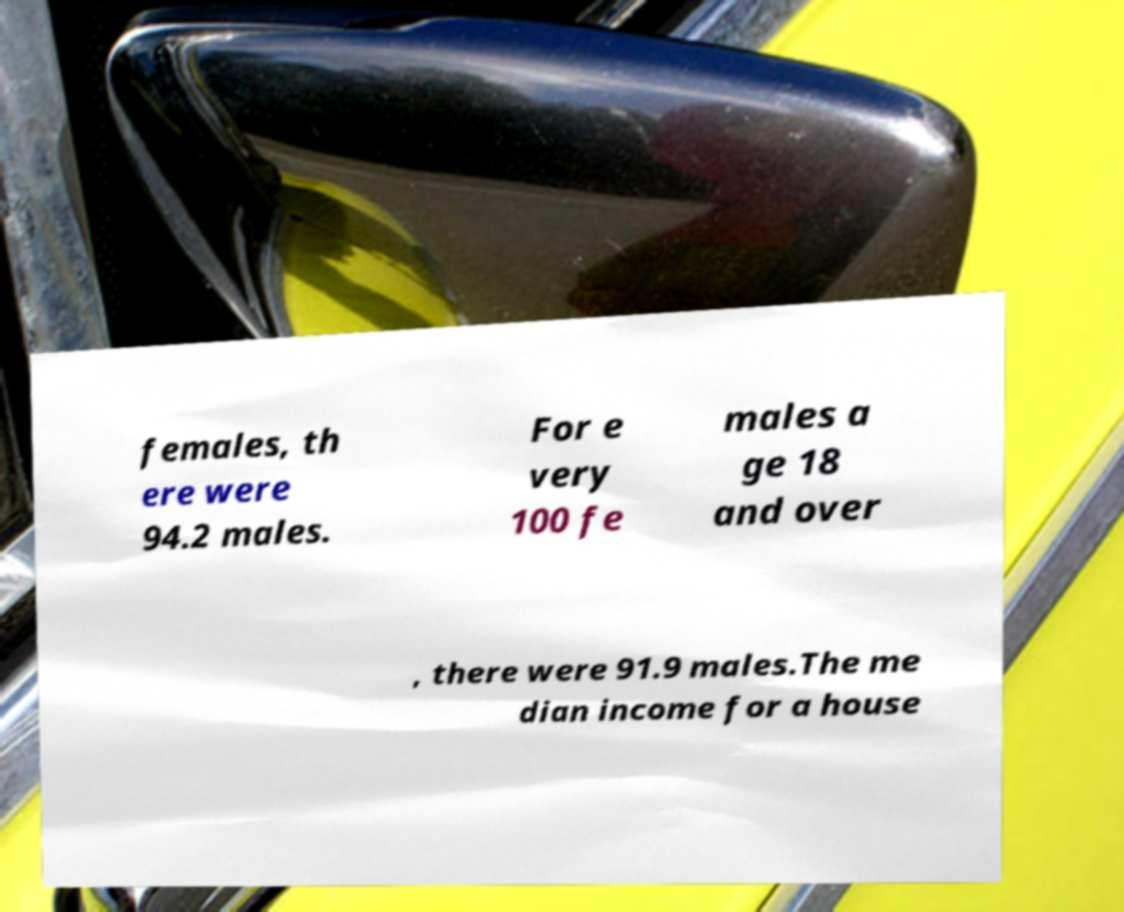Please read and relay the text visible in this image. What does it say? females, th ere were 94.2 males. For e very 100 fe males a ge 18 and over , there were 91.9 males.The me dian income for a house 